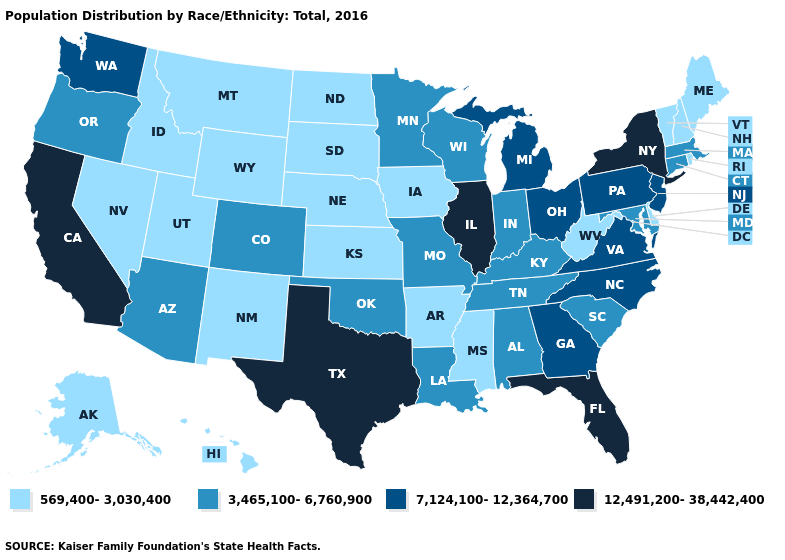Name the states that have a value in the range 569,400-3,030,400?
Answer briefly. Alaska, Arkansas, Delaware, Hawaii, Idaho, Iowa, Kansas, Maine, Mississippi, Montana, Nebraska, Nevada, New Hampshire, New Mexico, North Dakota, Rhode Island, South Dakota, Utah, Vermont, West Virginia, Wyoming. Does the first symbol in the legend represent the smallest category?
Quick response, please. Yes. What is the lowest value in states that border Minnesota?
Write a very short answer. 569,400-3,030,400. Name the states that have a value in the range 7,124,100-12,364,700?
Write a very short answer. Georgia, Michigan, New Jersey, North Carolina, Ohio, Pennsylvania, Virginia, Washington. Name the states that have a value in the range 569,400-3,030,400?
Write a very short answer. Alaska, Arkansas, Delaware, Hawaii, Idaho, Iowa, Kansas, Maine, Mississippi, Montana, Nebraska, Nevada, New Hampshire, New Mexico, North Dakota, Rhode Island, South Dakota, Utah, Vermont, West Virginia, Wyoming. What is the value of Illinois?
Give a very brief answer. 12,491,200-38,442,400. Does Indiana have a lower value than North Dakota?
Quick response, please. No. What is the value of Arkansas?
Be succinct. 569,400-3,030,400. What is the value of Tennessee?
Write a very short answer. 3,465,100-6,760,900. Which states have the highest value in the USA?
Answer briefly. California, Florida, Illinois, New York, Texas. What is the lowest value in the USA?
Keep it brief. 569,400-3,030,400. Does Rhode Island have the lowest value in the Northeast?
Answer briefly. Yes. Does New York have the highest value in the Northeast?
Keep it brief. Yes. What is the value of Nevada?
Short answer required. 569,400-3,030,400. Does the map have missing data?
Write a very short answer. No. 